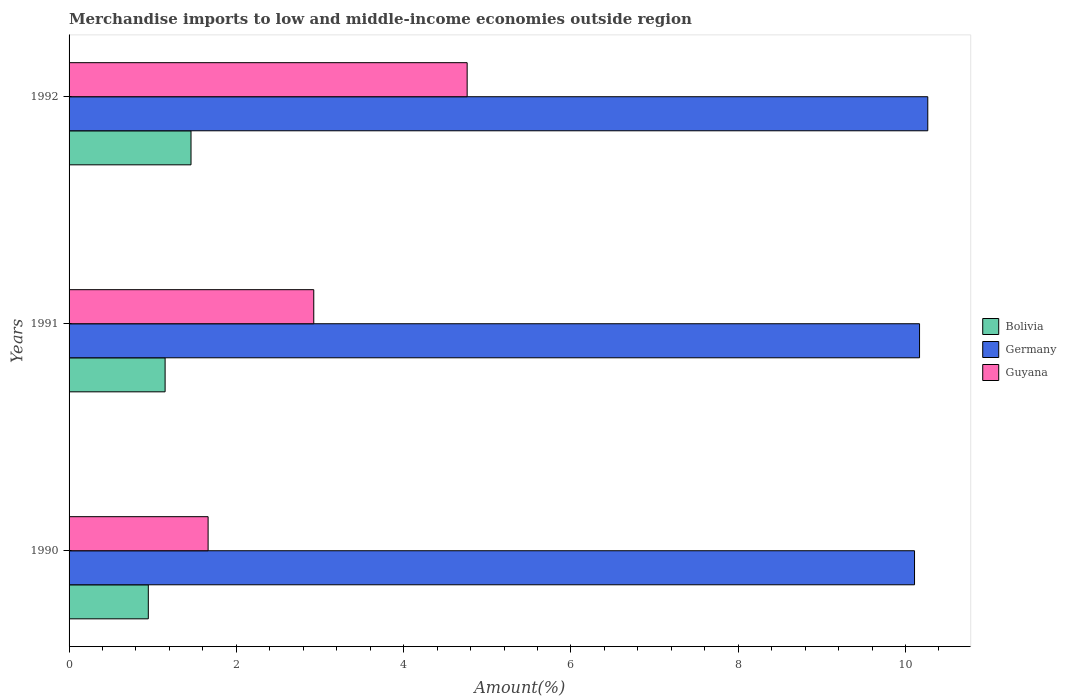How many bars are there on the 1st tick from the top?
Your answer should be very brief. 3. What is the label of the 1st group of bars from the top?
Ensure brevity in your answer.  1992. In how many cases, is the number of bars for a given year not equal to the number of legend labels?
Your answer should be compact. 0. What is the percentage of amount earned from merchandise imports in Germany in 1991?
Your response must be concise. 10.17. Across all years, what is the maximum percentage of amount earned from merchandise imports in Germany?
Offer a terse response. 10.27. Across all years, what is the minimum percentage of amount earned from merchandise imports in Guyana?
Offer a very short reply. 1.66. What is the total percentage of amount earned from merchandise imports in Germany in the graph?
Offer a terse response. 30.54. What is the difference between the percentage of amount earned from merchandise imports in Bolivia in 1990 and that in 1991?
Make the answer very short. -0.2. What is the difference between the percentage of amount earned from merchandise imports in Germany in 1992 and the percentage of amount earned from merchandise imports in Guyana in 1991?
Your answer should be very brief. 7.34. What is the average percentage of amount earned from merchandise imports in Guyana per year?
Your response must be concise. 3.12. In the year 1991, what is the difference between the percentage of amount earned from merchandise imports in Guyana and percentage of amount earned from merchandise imports in Bolivia?
Ensure brevity in your answer.  1.78. What is the ratio of the percentage of amount earned from merchandise imports in Bolivia in 1990 to that in 1991?
Your response must be concise. 0.83. Is the percentage of amount earned from merchandise imports in Guyana in 1991 less than that in 1992?
Ensure brevity in your answer.  Yes. What is the difference between the highest and the second highest percentage of amount earned from merchandise imports in Bolivia?
Give a very brief answer. 0.31. What is the difference between the highest and the lowest percentage of amount earned from merchandise imports in Bolivia?
Make the answer very short. 0.51. In how many years, is the percentage of amount earned from merchandise imports in Bolivia greater than the average percentage of amount earned from merchandise imports in Bolivia taken over all years?
Make the answer very short. 1. Is the sum of the percentage of amount earned from merchandise imports in Guyana in 1990 and 1991 greater than the maximum percentage of amount earned from merchandise imports in Germany across all years?
Your response must be concise. No. What does the 1st bar from the top in 1990 represents?
Offer a very short reply. Guyana. Is it the case that in every year, the sum of the percentage of amount earned from merchandise imports in Guyana and percentage of amount earned from merchandise imports in Bolivia is greater than the percentage of amount earned from merchandise imports in Germany?
Provide a succinct answer. No. What is the difference between two consecutive major ticks on the X-axis?
Your answer should be very brief. 2. Are the values on the major ticks of X-axis written in scientific E-notation?
Your response must be concise. No. How are the legend labels stacked?
Ensure brevity in your answer.  Vertical. What is the title of the graph?
Offer a very short reply. Merchandise imports to low and middle-income economies outside region. What is the label or title of the X-axis?
Ensure brevity in your answer.  Amount(%). What is the label or title of the Y-axis?
Your answer should be compact. Years. What is the Amount(%) of Bolivia in 1990?
Provide a short and direct response. 0.95. What is the Amount(%) in Germany in 1990?
Offer a very short reply. 10.11. What is the Amount(%) of Guyana in 1990?
Provide a succinct answer. 1.66. What is the Amount(%) in Bolivia in 1991?
Give a very brief answer. 1.15. What is the Amount(%) of Germany in 1991?
Your answer should be very brief. 10.17. What is the Amount(%) of Guyana in 1991?
Keep it short and to the point. 2.93. What is the Amount(%) of Bolivia in 1992?
Make the answer very short. 1.46. What is the Amount(%) in Germany in 1992?
Your answer should be compact. 10.27. What is the Amount(%) of Guyana in 1992?
Provide a short and direct response. 4.76. Across all years, what is the maximum Amount(%) of Bolivia?
Provide a succinct answer. 1.46. Across all years, what is the maximum Amount(%) in Germany?
Provide a short and direct response. 10.27. Across all years, what is the maximum Amount(%) of Guyana?
Give a very brief answer. 4.76. Across all years, what is the minimum Amount(%) in Bolivia?
Your answer should be compact. 0.95. Across all years, what is the minimum Amount(%) in Germany?
Your answer should be very brief. 10.11. Across all years, what is the minimum Amount(%) of Guyana?
Your answer should be compact. 1.66. What is the total Amount(%) of Bolivia in the graph?
Your answer should be compact. 3.55. What is the total Amount(%) of Germany in the graph?
Your answer should be compact. 30.54. What is the total Amount(%) of Guyana in the graph?
Provide a succinct answer. 9.35. What is the difference between the Amount(%) in Bolivia in 1990 and that in 1991?
Offer a terse response. -0.2. What is the difference between the Amount(%) in Germany in 1990 and that in 1991?
Ensure brevity in your answer.  -0.06. What is the difference between the Amount(%) in Guyana in 1990 and that in 1991?
Keep it short and to the point. -1.26. What is the difference between the Amount(%) in Bolivia in 1990 and that in 1992?
Provide a succinct answer. -0.51. What is the difference between the Amount(%) of Germany in 1990 and that in 1992?
Provide a succinct answer. -0.16. What is the difference between the Amount(%) in Guyana in 1990 and that in 1992?
Your answer should be very brief. -3.1. What is the difference between the Amount(%) in Bolivia in 1991 and that in 1992?
Your response must be concise. -0.31. What is the difference between the Amount(%) in Germany in 1991 and that in 1992?
Offer a terse response. -0.1. What is the difference between the Amount(%) of Guyana in 1991 and that in 1992?
Your response must be concise. -1.83. What is the difference between the Amount(%) in Bolivia in 1990 and the Amount(%) in Germany in 1991?
Your answer should be very brief. -9.22. What is the difference between the Amount(%) of Bolivia in 1990 and the Amount(%) of Guyana in 1991?
Make the answer very short. -1.98. What is the difference between the Amount(%) in Germany in 1990 and the Amount(%) in Guyana in 1991?
Offer a terse response. 7.18. What is the difference between the Amount(%) of Bolivia in 1990 and the Amount(%) of Germany in 1992?
Your answer should be very brief. -9.32. What is the difference between the Amount(%) in Bolivia in 1990 and the Amount(%) in Guyana in 1992?
Keep it short and to the point. -3.81. What is the difference between the Amount(%) of Germany in 1990 and the Amount(%) of Guyana in 1992?
Give a very brief answer. 5.35. What is the difference between the Amount(%) in Bolivia in 1991 and the Amount(%) in Germany in 1992?
Your answer should be very brief. -9.12. What is the difference between the Amount(%) in Bolivia in 1991 and the Amount(%) in Guyana in 1992?
Keep it short and to the point. -3.61. What is the difference between the Amount(%) in Germany in 1991 and the Amount(%) in Guyana in 1992?
Ensure brevity in your answer.  5.41. What is the average Amount(%) of Bolivia per year?
Ensure brevity in your answer.  1.18. What is the average Amount(%) of Germany per year?
Give a very brief answer. 10.18. What is the average Amount(%) of Guyana per year?
Offer a terse response. 3.12. In the year 1990, what is the difference between the Amount(%) of Bolivia and Amount(%) of Germany?
Provide a succinct answer. -9.16. In the year 1990, what is the difference between the Amount(%) of Bolivia and Amount(%) of Guyana?
Provide a succinct answer. -0.71. In the year 1990, what is the difference between the Amount(%) of Germany and Amount(%) of Guyana?
Your answer should be compact. 8.45. In the year 1991, what is the difference between the Amount(%) in Bolivia and Amount(%) in Germany?
Offer a terse response. -9.02. In the year 1991, what is the difference between the Amount(%) in Bolivia and Amount(%) in Guyana?
Provide a short and direct response. -1.78. In the year 1991, what is the difference between the Amount(%) in Germany and Amount(%) in Guyana?
Your response must be concise. 7.24. In the year 1992, what is the difference between the Amount(%) of Bolivia and Amount(%) of Germany?
Your response must be concise. -8.81. In the year 1992, what is the difference between the Amount(%) of Bolivia and Amount(%) of Guyana?
Your answer should be compact. -3.3. In the year 1992, what is the difference between the Amount(%) of Germany and Amount(%) of Guyana?
Make the answer very short. 5.51. What is the ratio of the Amount(%) of Bolivia in 1990 to that in 1991?
Keep it short and to the point. 0.83. What is the ratio of the Amount(%) of Germany in 1990 to that in 1991?
Ensure brevity in your answer.  0.99. What is the ratio of the Amount(%) of Guyana in 1990 to that in 1991?
Make the answer very short. 0.57. What is the ratio of the Amount(%) of Bolivia in 1990 to that in 1992?
Make the answer very short. 0.65. What is the ratio of the Amount(%) in Germany in 1990 to that in 1992?
Ensure brevity in your answer.  0.98. What is the ratio of the Amount(%) in Guyana in 1990 to that in 1992?
Keep it short and to the point. 0.35. What is the ratio of the Amount(%) of Bolivia in 1991 to that in 1992?
Your response must be concise. 0.79. What is the ratio of the Amount(%) in Guyana in 1991 to that in 1992?
Provide a succinct answer. 0.61. What is the difference between the highest and the second highest Amount(%) in Bolivia?
Ensure brevity in your answer.  0.31. What is the difference between the highest and the second highest Amount(%) of Germany?
Your answer should be very brief. 0.1. What is the difference between the highest and the second highest Amount(%) of Guyana?
Your response must be concise. 1.83. What is the difference between the highest and the lowest Amount(%) of Bolivia?
Offer a terse response. 0.51. What is the difference between the highest and the lowest Amount(%) in Germany?
Provide a short and direct response. 0.16. What is the difference between the highest and the lowest Amount(%) in Guyana?
Your response must be concise. 3.1. 